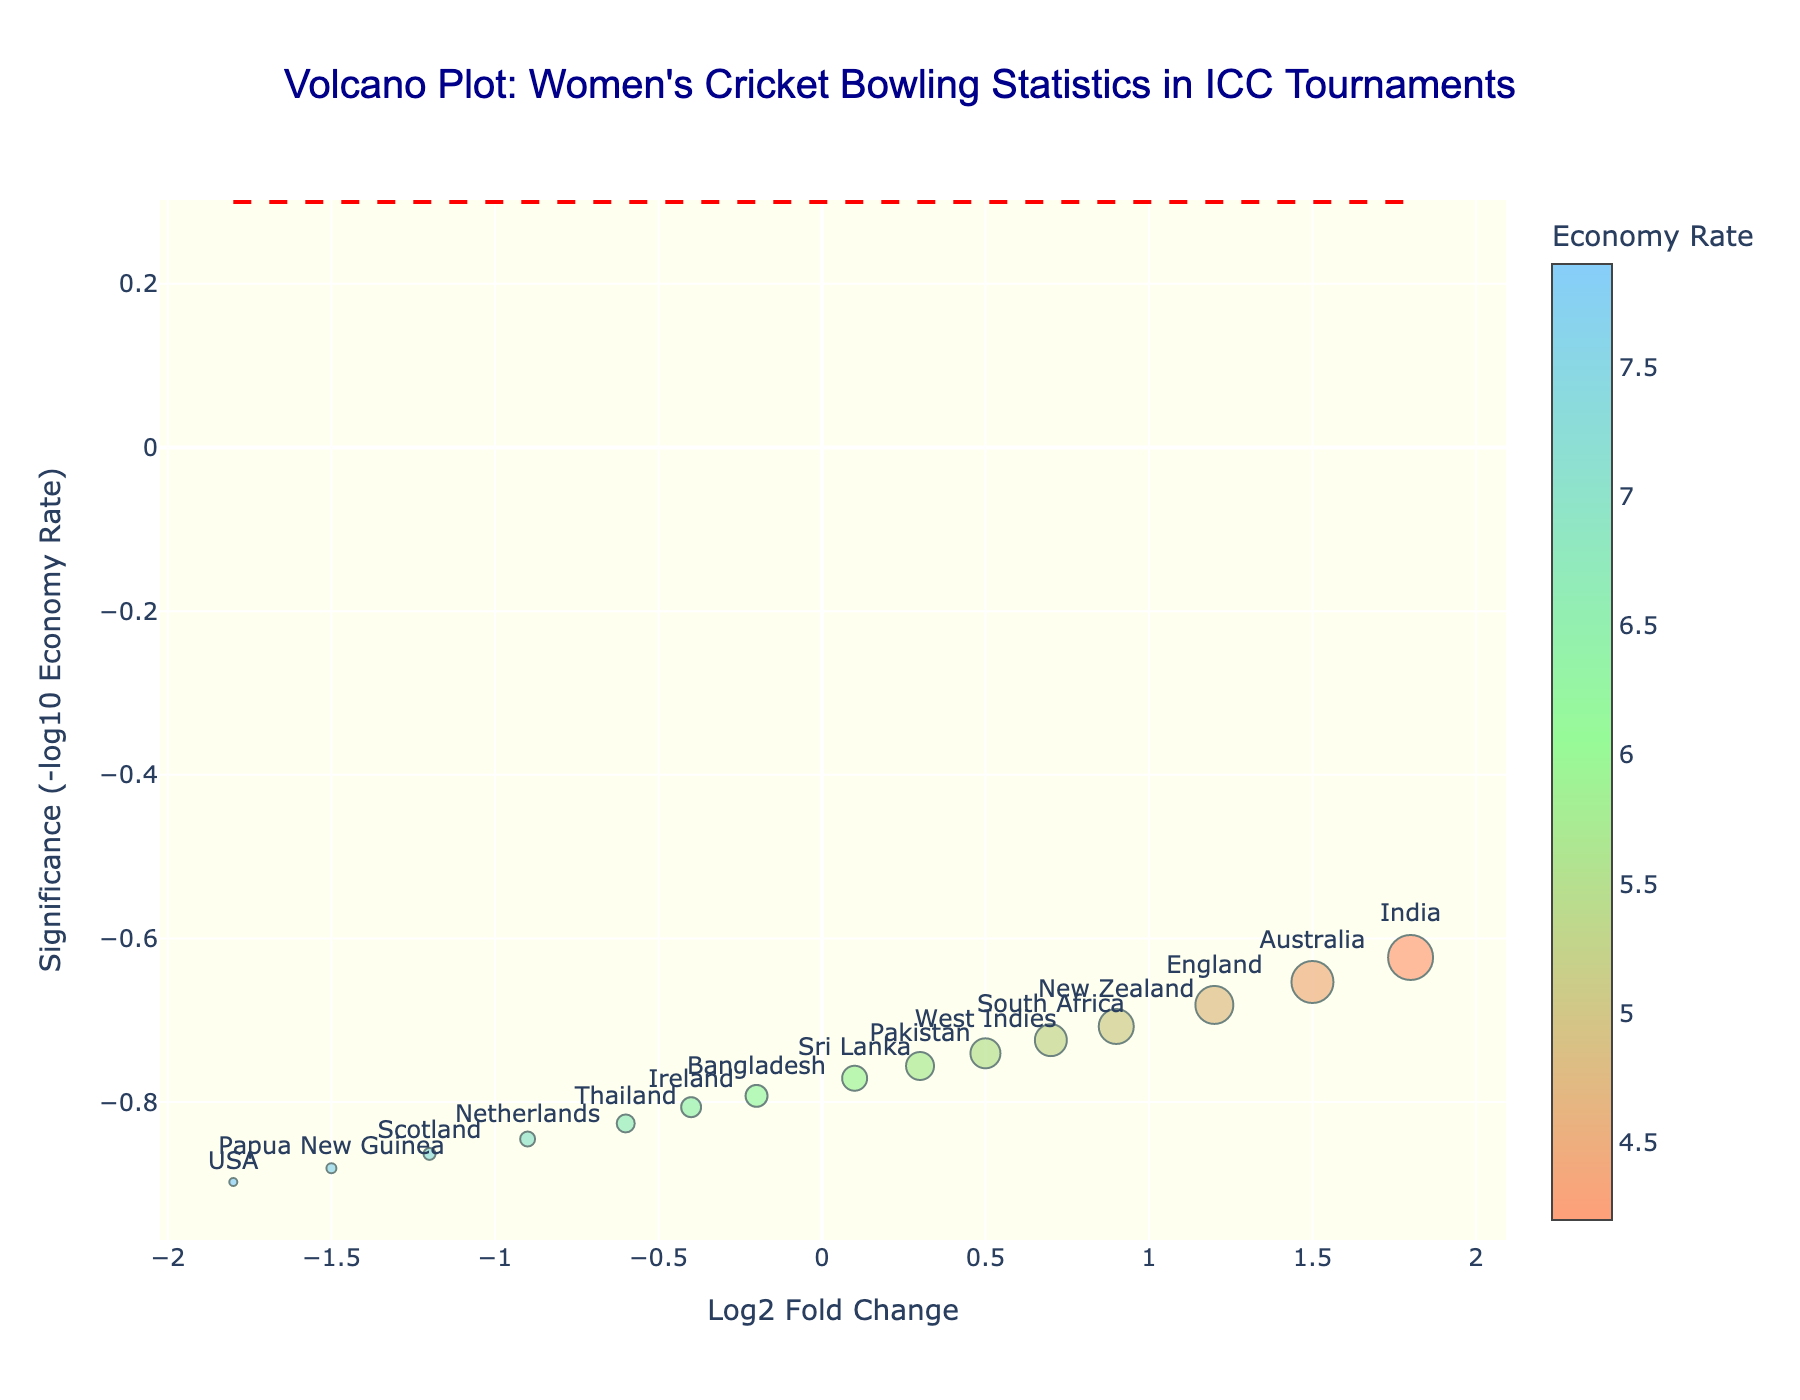What's the main title of the plot? The main title is always at the top of the plot and provides a concise summary of what the plot represents. In this case, it mentions women's cricket bowling statistics in ICC tournaments.
Answer: Volcano Plot: Women's Cricket Bowling Statistics in ICC Tournaments How is the significance of the economy rate visually represented? Significance is visually represented by the y-axis titled "Significance (-log10 Economy Rate)," which means the significance value is calculated as the negative log10 of the economy rates.
Answer: By the y-axis labeled "Significance (-log10 Economy Rate)" What does the x-axis represent in the plot? The x-axis represents the Log2 Fold Change, which is indicated by the x-axis title. This typically shows the logarithmic change in a variable compared to a reference point.
Answer: Log2 Fold Change Which team took the most wickets in the tournament, according to the plot? By observing the size of the markers on the plot (indicating wickets taken) and the hover information provided, the team with the largest marker is India.
Answer: India How does the economy rate of Australia compare to that of India? The color of the markers corresponds to the economy rates, where lighter colors indicate lower economy rates. By comparing the colors, Australia's marker is slightly darker than India's, indicating a higher economy rate.
Answer: Higher Which team has the highest economy rate according to the plot? The highest economy rate would be denoted by the darkest color in the plot and can also be verified by checking the color bar on the plot. The team indicated at the highest value in this range is the USA.
Answer: USA Of all the teams with a negative Log2 Fold Change, which team took the fewest wickets? By checking the left side of the plot (negative Log2 Fold Change) and observing the smallest marker, Papua New Guinea has the smallest marker in this region.
Answer: Papua New Guinea Identify the team with a significance level above the dashed horizontal line and the highest economy rate among them. The dashed horizontal line marks a significance threshold. Checking teams above this line with color comparison for the darkest marker, Sri Lanka is among the highest in this group.
Answer: Sri Lanka If the average economy rate decreases by 0.5 for all teams, which team would then have a significance just below 0.3? First, find the team closest above 0.3 significance (Scotland at approximately 0.27). Reducing each team's economy rate by 0.5, Netherlands with current 7.0 would fall to 6.5 and a recalculated significance slightly below 0.3.
Answer: Netherlands 